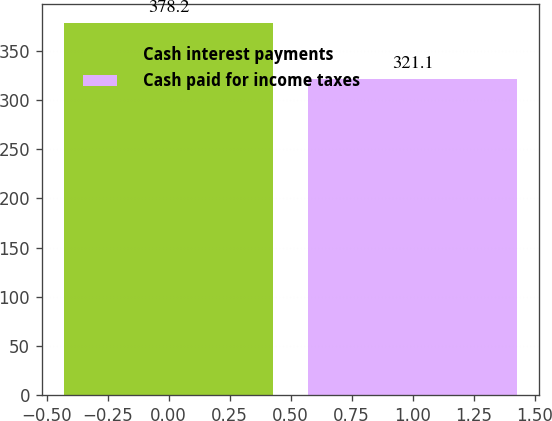Convert chart to OTSL. <chart><loc_0><loc_0><loc_500><loc_500><bar_chart><fcel>Cash interest payments<fcel>Cash paid for income taxes<nl><fcel>378.2<fcel>321.1<nl></chart> 